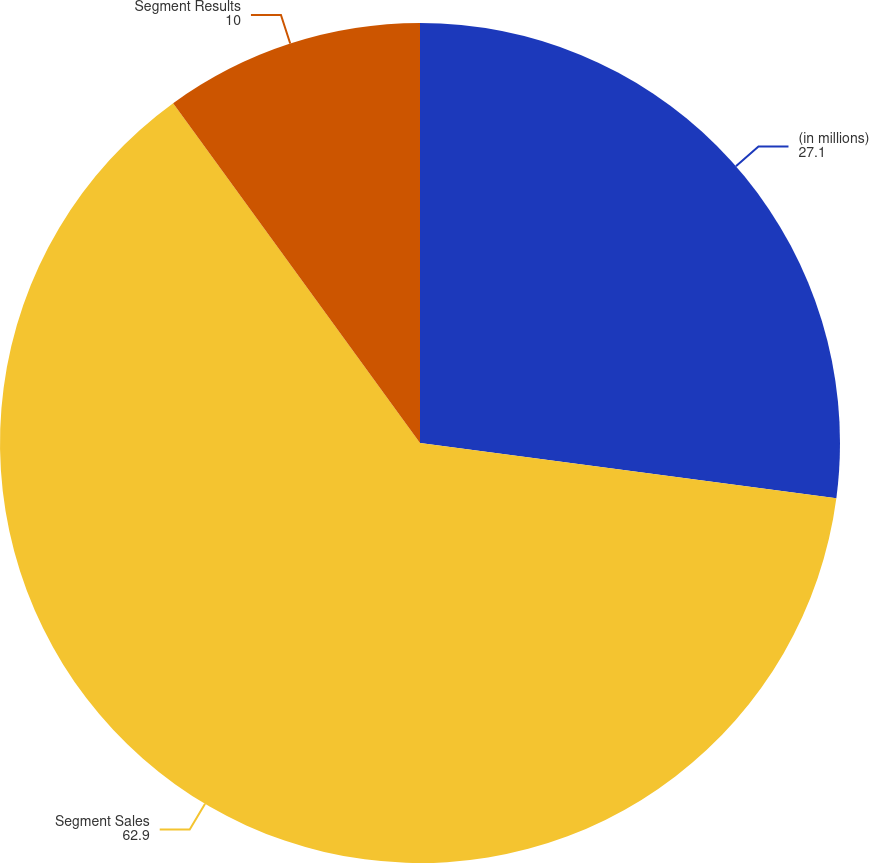Convert chart to OTSL. <chart><loc_0><loc_0><loc_500><loc_500><pie_chart><fcel>(in millions)<fcel>Segment Sales<fcel>Segment Results<nl><fcel>27.1%<fcel>62.9%<fcel>10.0%<nl></chart> 